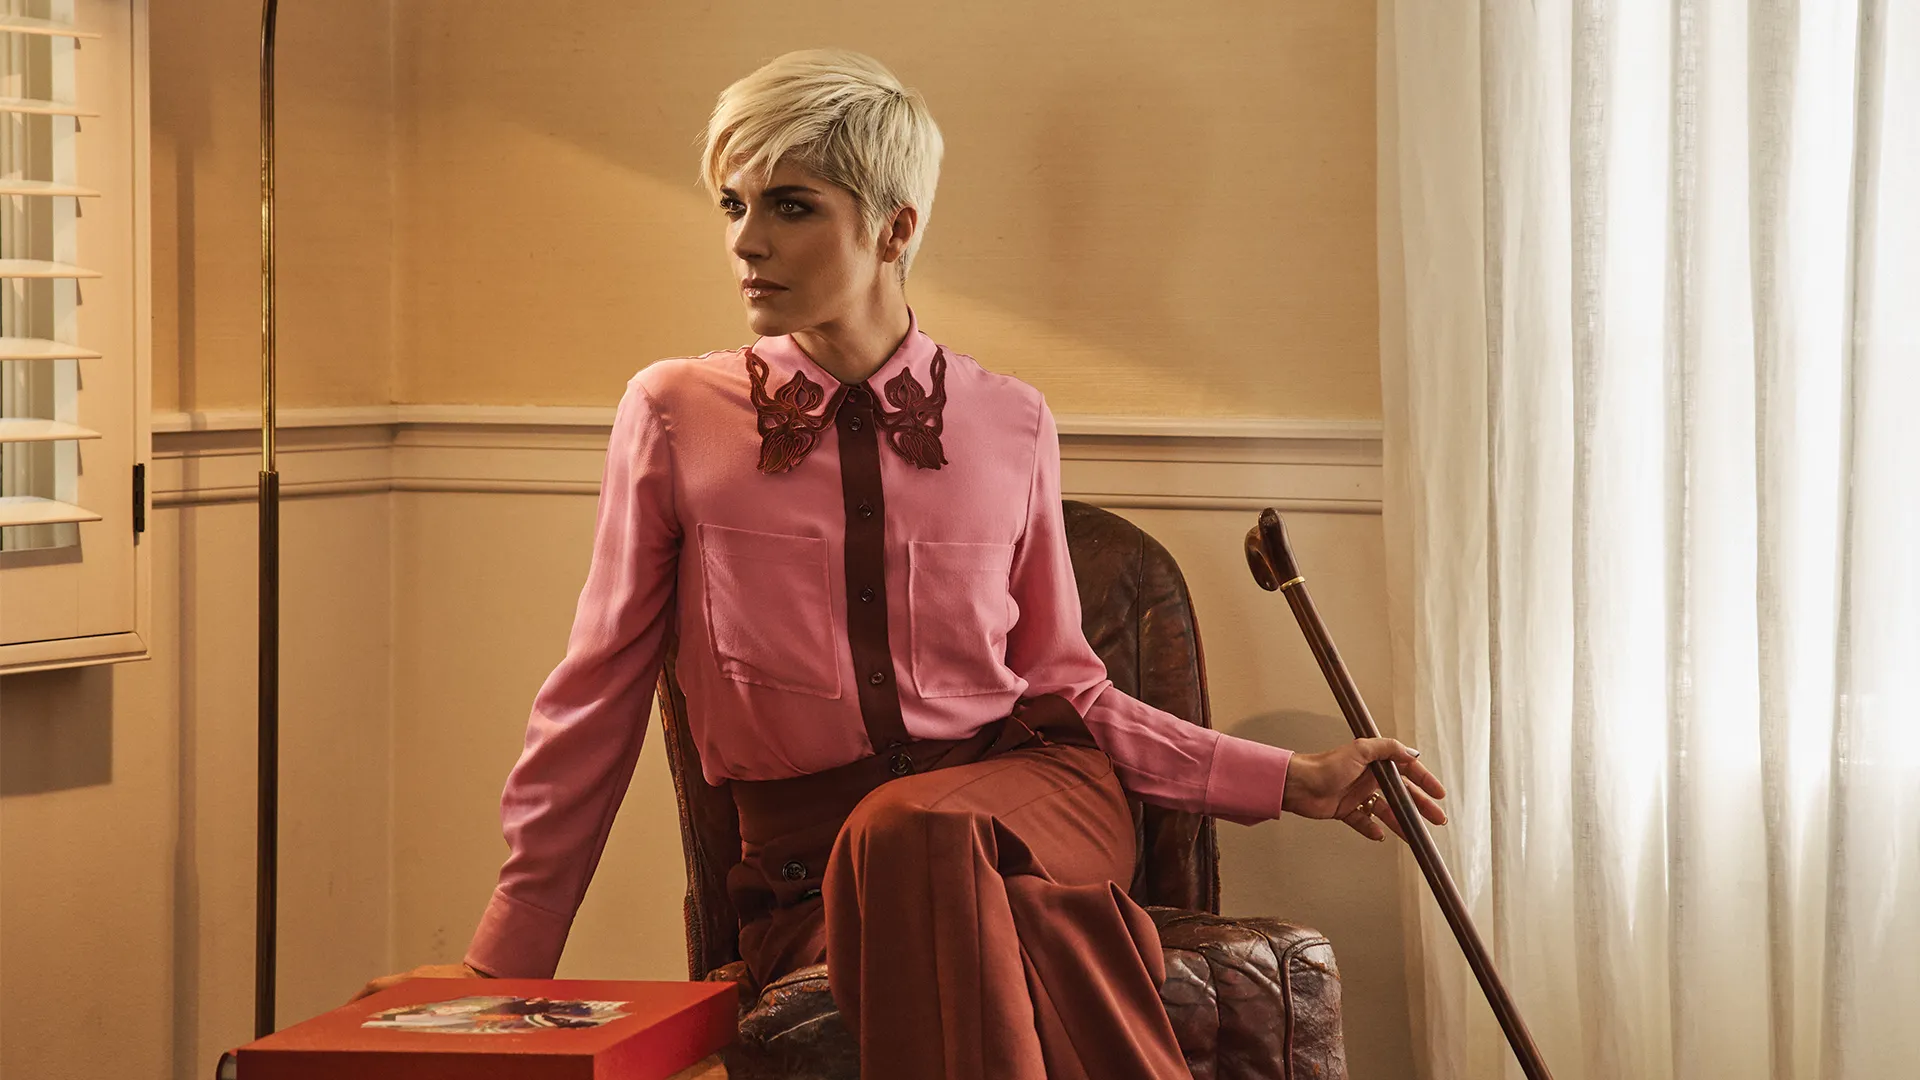Where might this scene be taking place in a broader narrative? This scene could be set in a quiet afternoon at Evelyn’s home, perhaps in her study room where she likes to spend time reflecting and reliving memories from her past. The serene environment could represent a moment just before she heads out to teach her dance class, where her students await her guidance and wisdom. Alternatively, this could be after a long day of mentoring, where she takes a few moments alone to gather her thoughts and reminisce about her journey. Can you create a very imaginative scenario for this image? In an alternate universe, Evelyn is a guardian of ancient, mystical realms. The red box is an enchanted artifact containing the keys to portals through which she travels to different worlds, protecting sacred knowledge and balancing cosmic energies. The cane is not just a support but a wand imbued with powerful spells. In this moment, she is contemplating her next mission – to save a world engulfed in chaos and restore harmony. The room she sits in is her sanctum, a place where the walls whisper the secrets of the cosmos, and the neutral tones serve to calm the turbulent energies she must channel. 